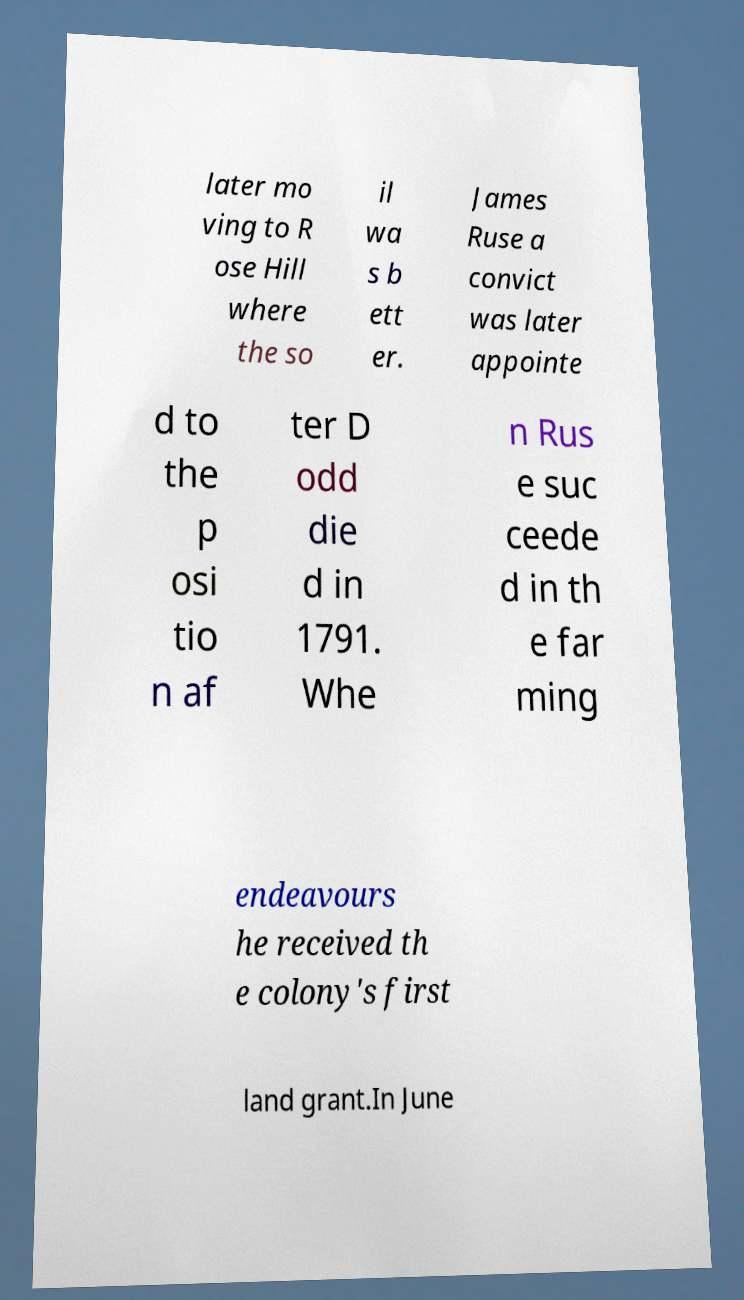For documentation purposes, I need the text within this image transcribed. Could you provide that? later mo ving to R ose Hill where the so il wa s b ett er. James Ruse a convict was later appointe d to the p osi tio n af ter D odd die d in 1791. Whe n Rus e suc ceede d in th e far ming endeavours he received th e colony's first land grant.In June 